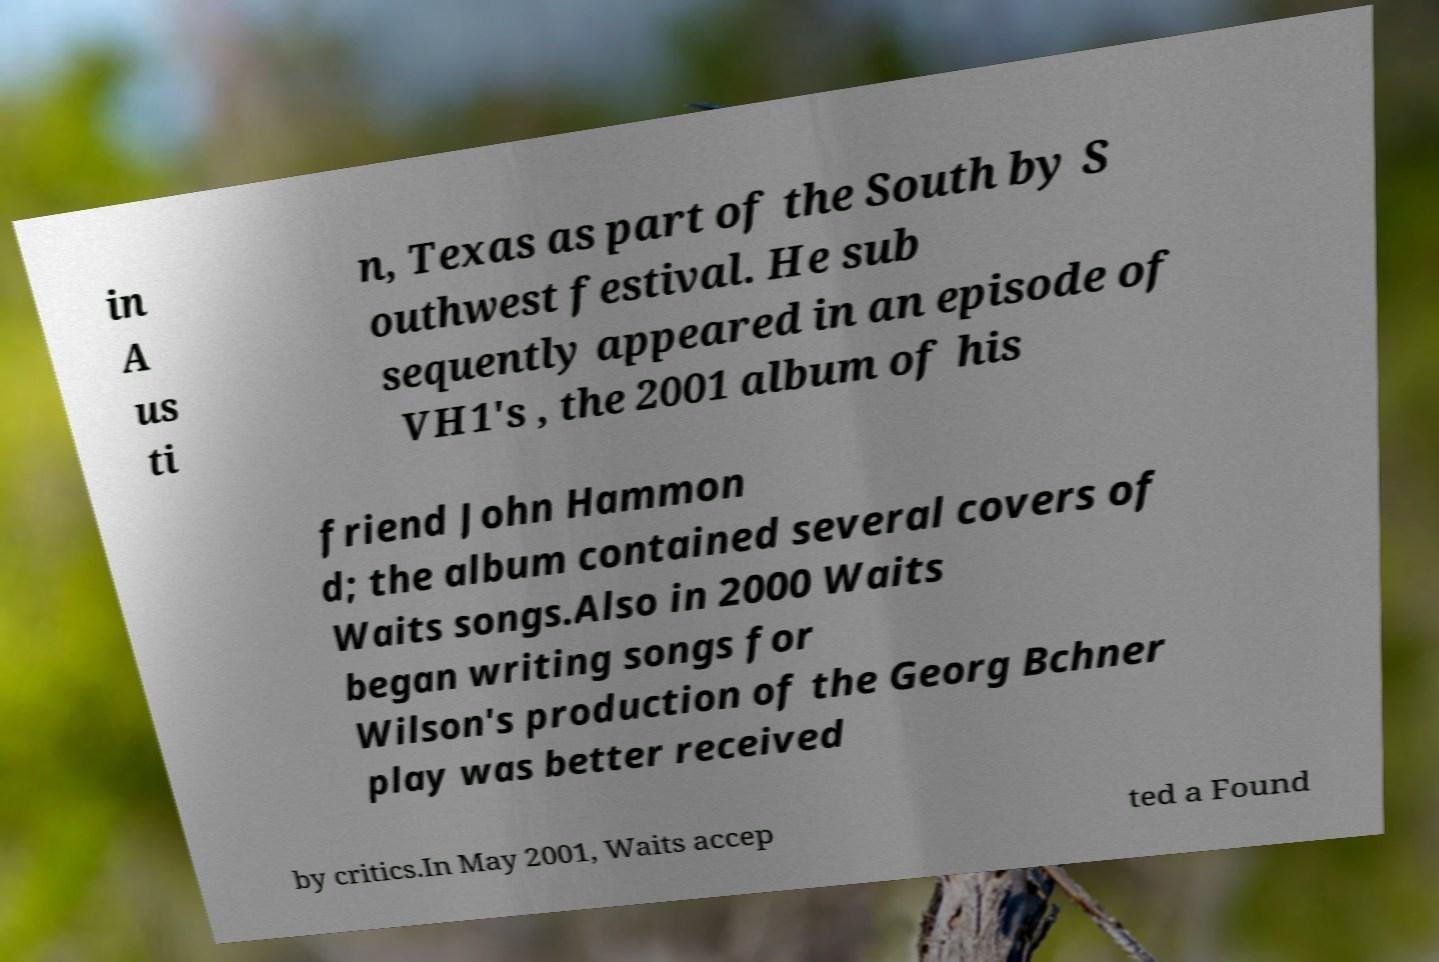What messages or text are displayed in this image? I need them in a readable, typed format. in A us ti n, Texas as part of the South by S outhwest festival. He sub sequently appeared in an episode of VH1's , the 2001 album of his friend John Hammon d; the album contained several covers of Waits songs.Also in 2000 Waits began writing songs for Wilson's production of the Georg Bchner play was better received by critics.In May 2001, Waits accep ted a Found 